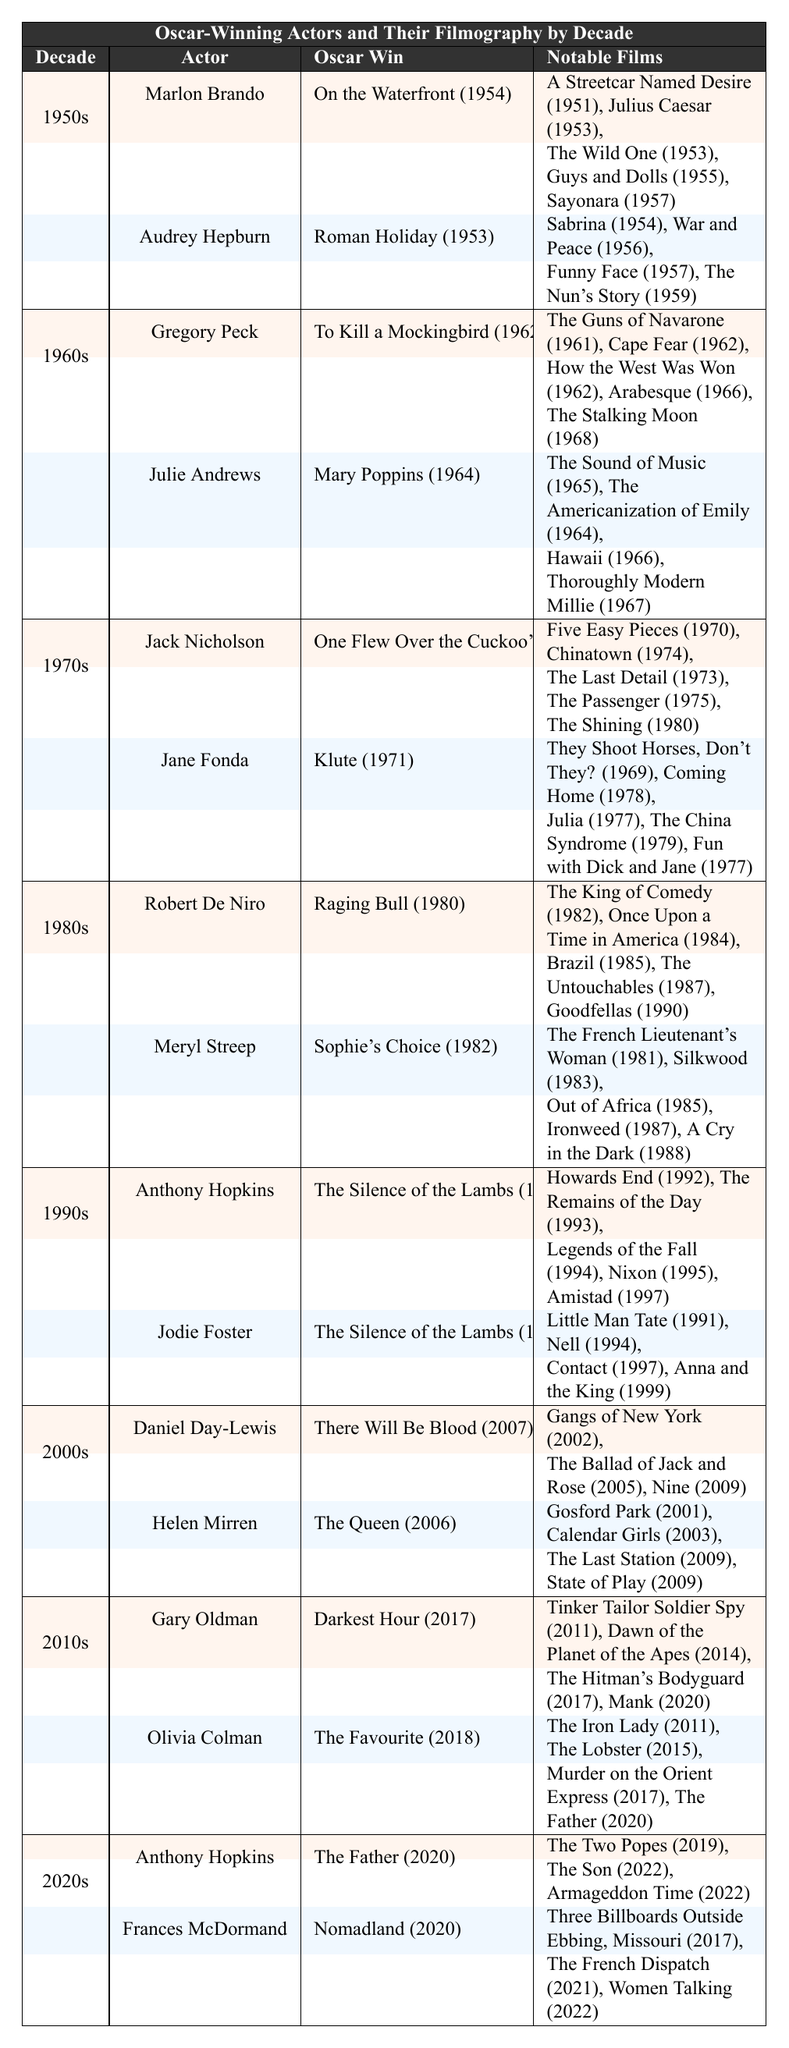What film did Audrey Hepburn win her Oscar for? Audrey Hepburn won her Oscar for "Roman Holiday" in 1953, as stated directly under her section in the table.
Answer: Roman Holiday Which actor has the most Oscar wins listed in the table? Both Anthony Hopkins and Jodie Foster are listed with two Oscar wins each for "The Silence of the Lambs" in 1991 and different films in other years. However, in terms of unique wins presented, there are no actors with more than one win in this specific table.
Answer: None In which decade did Jack Nicholson win his Oscar? The table lists Jack Nicholson under the 1970s category with the Oscar win for "One Flew Over the Cuckoo's Nest" (1975).
Answer: 1970s List one notable film by Meryl Streep. The table includes several notable films under Meryl Streep, such as "The French Lieutenant's Woman," which is one of the examples given in her section.
Answer: The French Lieutenant's Woman Which actor had an Oscar win for a film released most recently in the 2020s? The most recent Oscar win listed is for Anthony Hopkins for "The Father" in 2020, according to the table's information for the 2020s decade.
Answer: Anthony Hopkins How many notable films did Robert De Niro have listed? Robert De Niro has five notable films listed in the table, as seen in his section. A simple count of the films confirms there are indeed five.
Answer: 5 Is "The Sound of Music" listed as a notable film for any Oscar-winning actor? Yes, "The Sound of Music" is listed under Julie Andrews, who won an Oscar in the 1960s as noted in the table.
Answer: Yes Which actor won an Oscar in the 1980s and what was the film? Meryl Streep won her Oscar in the 1980s for "Sophie's Choice" in 1982, as per the decade's section in the table.
Answer: Meryl Streep, Sophie's Choice Who are the actors mentioned in the 1990s section? The table shows that the 1990s section includes Anthony Hopkins and Jodie Foster, each with wins for "The Silence of the Lambs."
Answer: Anthony Hopkins, Jodie Foster Determine if Helen Mirren's notable films were released before 2006. No, the films listed for Helen Mirren all come after 2001 and include "The Queen" as her Oscar-winning film in 2006. Thus, they cannot all be before that year, as the earliest notable film listed is from 2001.
Answer: No 